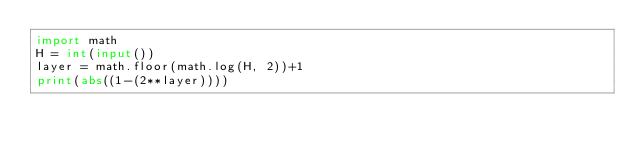<code> <loc_0><loc_0><loc_500><loc_500><_Python_>import math
H = int(input())
layer = math.floor(math.log(H, 2))+1
print(abs((1-(2**layer))))
</code> 